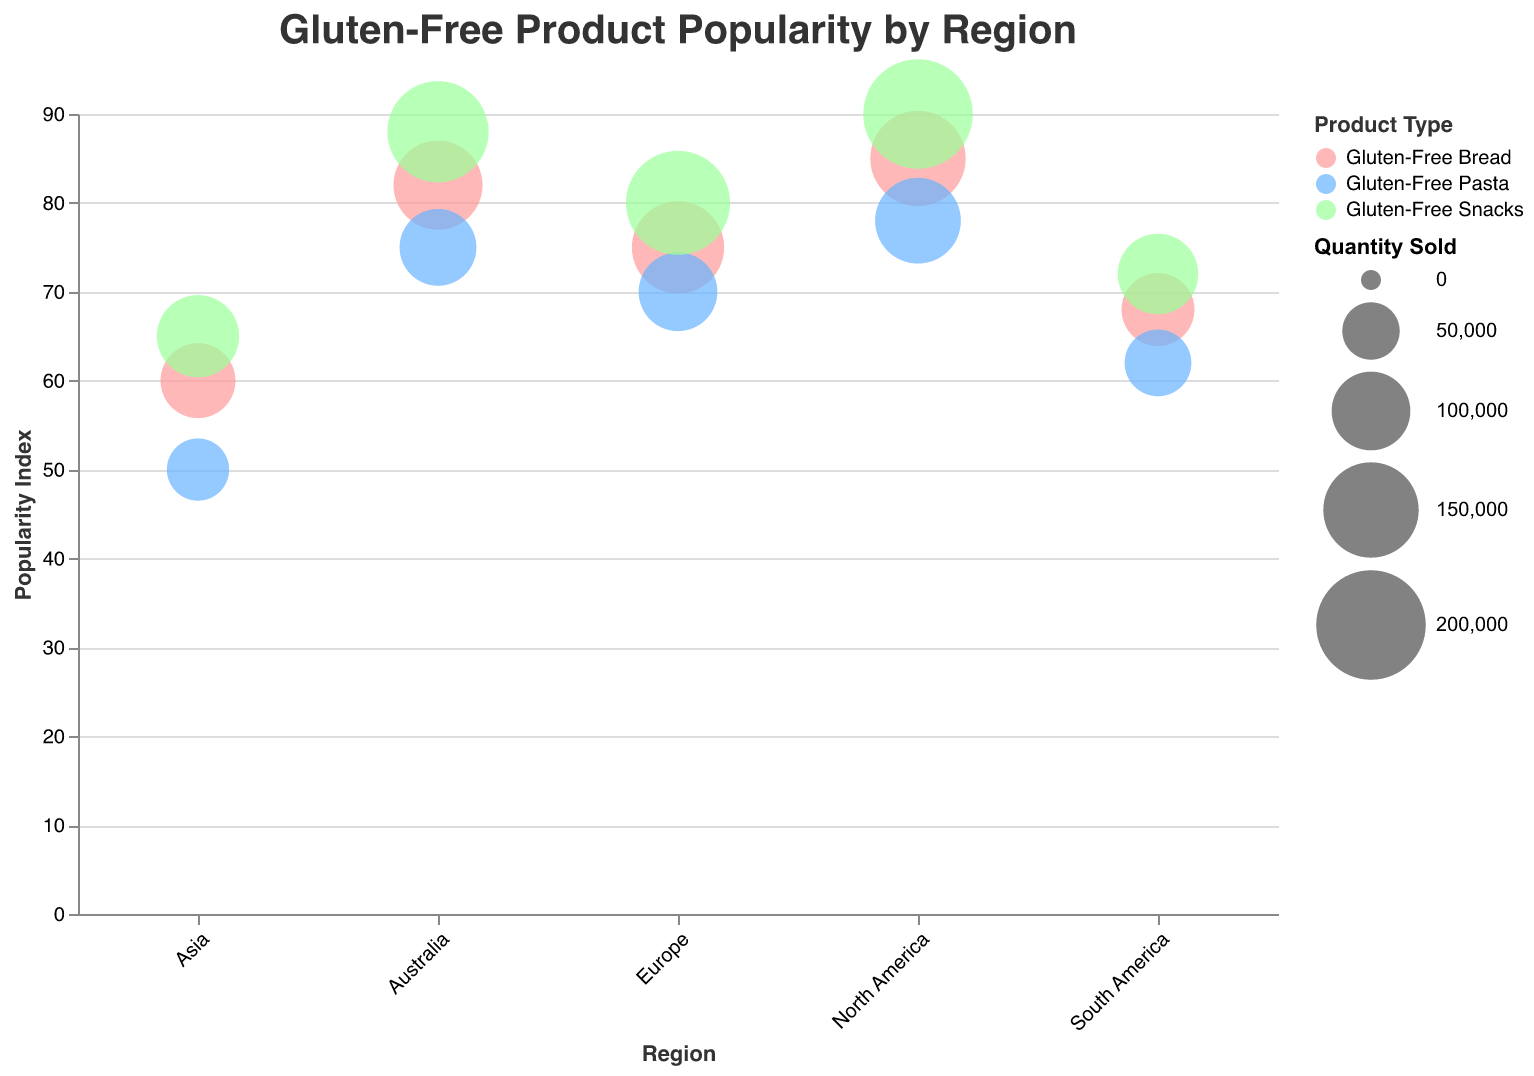What is the title of the figure? The title is displayed at the top of the chart and reads "Gluten-Free Product Popularity by Region".
Answer: Gluten-Free Product Popularity by Region What regions have the highest popularity index for gluten-free bread? Look at the y-axis which represents the popularity index and identify the bubbles representing gluten-free bread with the highest positions.
Answer: North America and Australia Which product type has the largest quantity sold in North America? Find the bubbles for each product type in North America and compare their sizes since the size of the bubbles represents the quantity sold.
Answer: Gluten-Free Snacks How does the popularity index of gluten-free pasta in Europe compare to that in Asia? Compare the y-axis values for gluten-free pasta between Europe and Asia. Europe’s popularity index for gluten-free pasta is 70, whereas Asia’s is 50.
Answer: Higher in Europe What is the total quantity of gluten-free products sold in South America? Sum the quantities sold of all three product types in South America: 85,000 (bread) + 70,000 (pasta) + 105,000 (snacks).
Answer: 260,000 Is the popularity index for gluten-free snacks always higher than that for gluten-free pasta in every region? Check and compare each region's bubbles for gluten-free snacks and pasta to see if the snacks' y-values (popularity) are always higher than the pasta’s.
Answer: Yes In which region is the quantity sold of gluten-free bread the lowest? Compare the bubble sizes representing gluten-free bread across all regions and find the smallest one.
Answer: South America Which region has the most consistent popularity index across all product types? Compare the spread of popularity index values (y-values) within each region to see which has the smallest spread.
Answer: Australia What is the average popularity index of gluten-free products in Asia? Calculate the mean of the popularity indices for bread, pasta, and snacks in Asia: (60 + 50 + 65) / 3.
Answer: 58.33 